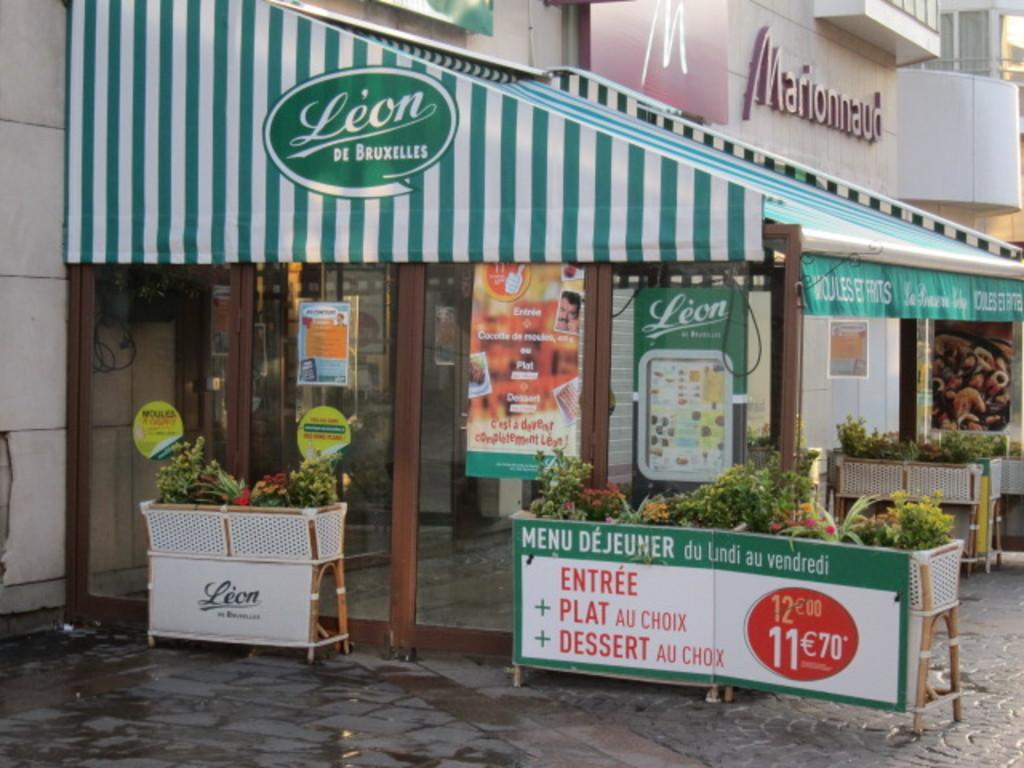What type of living organisms can be seen in the image? Plants can be seen in the image. What type of structure is present in the image? There is a building in the image. What type of decorations are visible in the image? There are posters in the image. What material is present in the image that is transparent or translucent? There is glass in the image. What type of drink is being served in the image? There is no drink present in the image. What type of bun is being used to hold the plants in the image? There are no buns present in the image; the plants are not being held by any bun-like objects. 